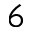<formula> <loc_0><loc_0><loc_500><loc_500>6</formula> 